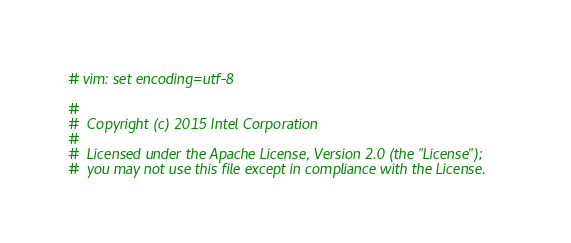Convert code to text. <code><loc_0><loc_0><loc_500><loc_500><_Python_># vim: set encoding=utf-8

#
#  Copyright (c) 2015 Intel Corporation 
#
#  Licensed under the Apache License, Version 2.0 (the "License");
#  you may not use this file except in compliance with the License.</code> 